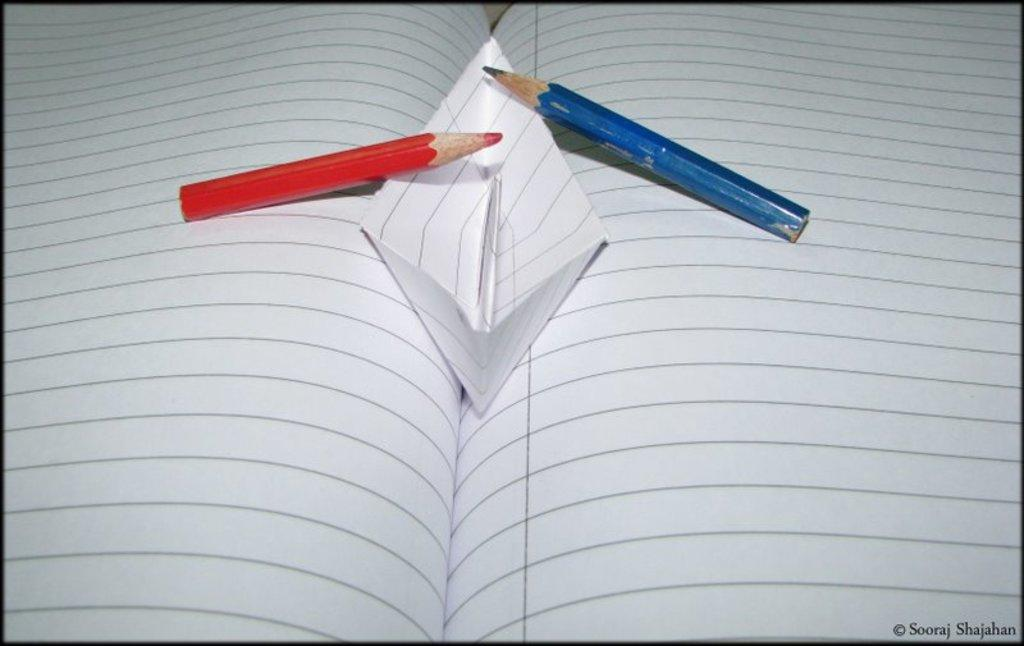What is the main object in the image? There is an opened book in the image. What is placed on top of the book? There are pencils and a paper boat on the book. Where is the writing located in the image? The writing is in the right bottom corner of the image. How many oranges are being used as a beam to support the ship in the image? There are no oranges, beam, or ship present in the image. 